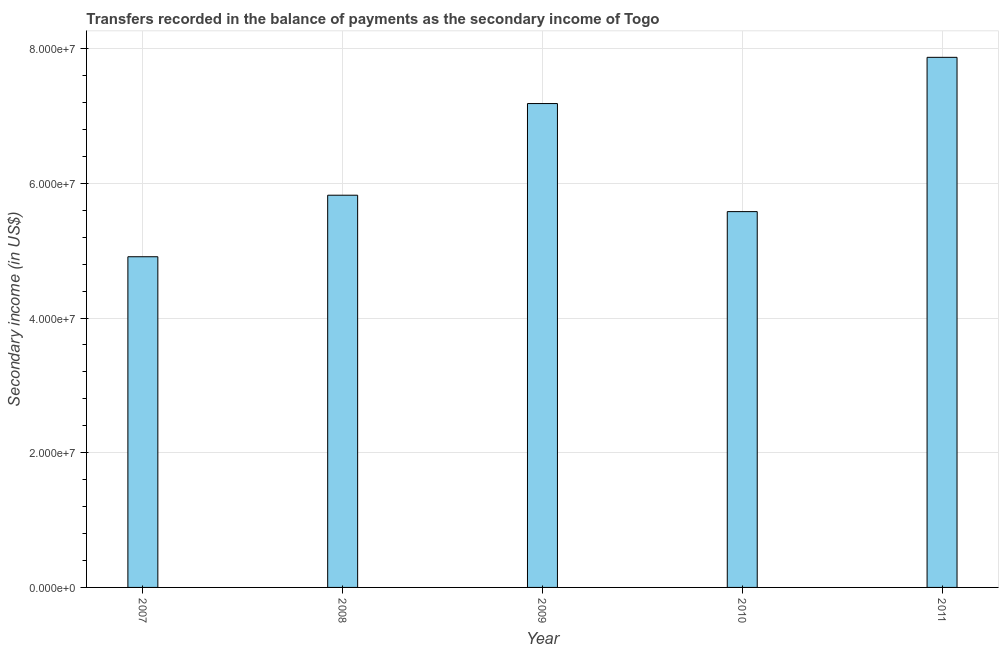What is the title of the graph?
Your response must be concise. Transfers recorded in the balance of payments as the secondary income of Togo. What is the label or title of the Y-axis?
Give a very brief answer. Secondary income (in US$). What is the amount of secondary income in 2008?
Give a very brief answer. 5.82e+07. Across all years, what is the maximum amount of secondary income?
Your answer should be compact. 7.87e+07. Across all years, what is the minimum amount of secondary income?
Provide a succinct answer. 4.91e+07. What is the sum of the amount of secondary income?
Offer a terse response. 3.14e+08. What is the difference between the amount of secondary income in 2008 and 2011?
Give a very brief answer. -2.05e+07. What is the average amount of secondary income per year?
Your response must be concise. 6.27e+07. What is the median amount of secondary income?
Provide a succinct answer. 5.82e+07. In how many years, is the amount of secondary income greater than 8000000 US$?
Offer a terse response. 5. What is the ratio of the amount of secondary income in 2007 to that in 2008?
Make the answer very short. 0.84. Is the amount of secondary income in 2008 less than that in 2009?
Offer a very short reply. Yes. What is the difference between the highest and the second highest amount of secondary income?
Your answer should be compact. 6.86e+06. Is the sum of the amount of secondary income in 2009 and 2010 greater than the maximum amount of secondary income across all years?
Your answer should be compact. Yes. What is the difference between the highest and the lowest amount of secondary income?
Your answer should be compact. 2.96e+07. In how many years, is the amount of secondary income greater than the average amount of secondary income taken over all years?
Offer a terse response. 2. How many bars are there?
Offer a very short reply. 5. Are all the bars in the graph horizontal?
Give a very brief answer. No. What is the difference between two consecutive major ticks on the Y-axis?
Make the answer very short. 2.00e+07. What is the Secondary income (in US$) in 2007?
Keep it short and to the point. 4.91e+07. What is the Secondary income (in US$) in 2008?
Offer a terse response. 5.82e+07. What is the Secondary income (in US$) of 2009?
Provide a succinct answer. 7.19e+07. What is the Secondary income (in US$) of 2010?
Offer a terse response. 5.58e+07. What is the Secondary income (in US$) in 2011?
Make the answer very short. 7.87e+07. What is the difference between the Secondary income (in US$) in 2007 and 2008?
Ensure brevity in your answer.  -9.14e+06. What is the difference between the Secondary income (in US$) in 2007 and 2009?
Your response must be concise. -2.27e+07. What is the difference between the Secondary income (in US$) in 2007 and 2010?
Make the answer very short. -6.70e+06. What is the difference between the Secondary income (in US$) in 2007 and 2011?
Ensure brevity in your answer.  -2.96e+07. What is the difference between the Secondary income (in US$) in 2008 and 2009?
Your answer should be compact. -1.36e+07. What is the difference between the Secondary income (in US$) in 2008 and 2010?
Keep it short and to the point. 2.44e+06. What is the difference between the Secondary income (in US$) in 2008 and 2011?
Ensure brevity in your answer.  -2.05e+07. What is the difference between the Secondary income (in US$) in 2009 and 2010?
Give a very brief answer. 1.60e+07. What is the difference between the Secondary income (in US$) in 2009 and 2011?
Make the answer very short. -6.86e+06. What is the difference between the Secondary income (in US$) in 2010 and 2011?
Offer a terse response. -2.29e+07. What is the ratio of the Secondary income (in US$) in 2007 to that in 2008?
Your answer should be very brief. 0.84. What is the ratio of the Secondary income (in US$) in 2007 to that in 2009?
Your answer should be compact. 0.68. What is the ratio of the Secondary income (in US$) in 2007 to that in 2011?
Offer a very short reply. 0.62. What is the ratio of the Secondary income (in US$) in 2008 to that in 2009?
Your answer should be very brief. 0.81. What is the ratio of the Secondary income (in US$) in 2008 to that in 2010?
Your response must be concise. 1.04. What is the ratio of the Secondary income (in US$) in 2008 to that in 2011?
Ensure brevity in your answer.  0.74. What is the ratio of the Secondary income (in US$) in 2009 to that in 2010?
Provide a succinct answer. 1.29. What is the ratio of the Secondary income (in US$) in 2010 to that in 2011?
Provide a succinct answer. 0.71. 